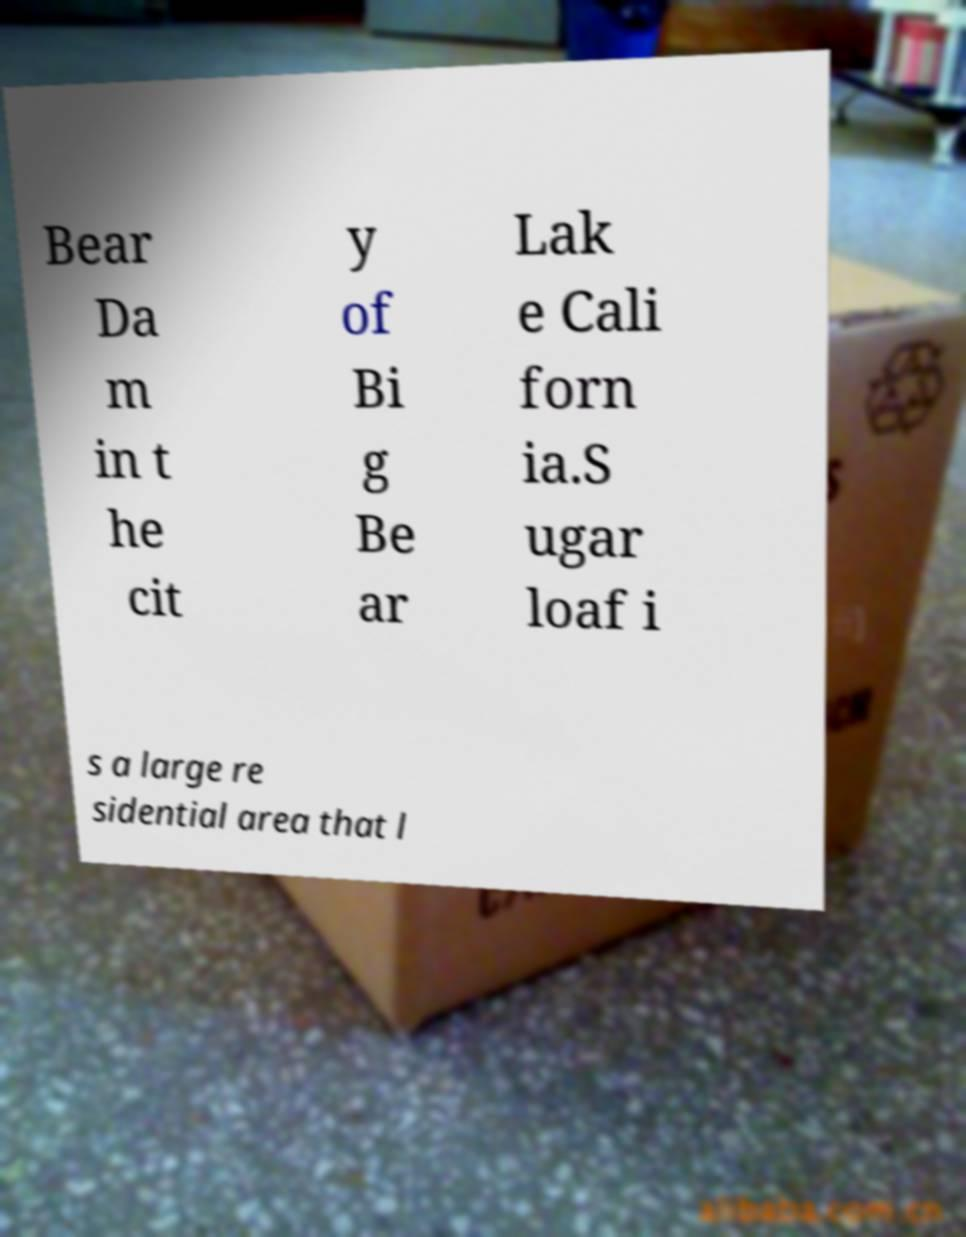Could you assist in decoding the text presented in this image and type it out clearly? Bear Da m in t he cit y of Bi g Be ar Lak e Cali forn ia.S ugar loaf i s a large re sidential area that l 